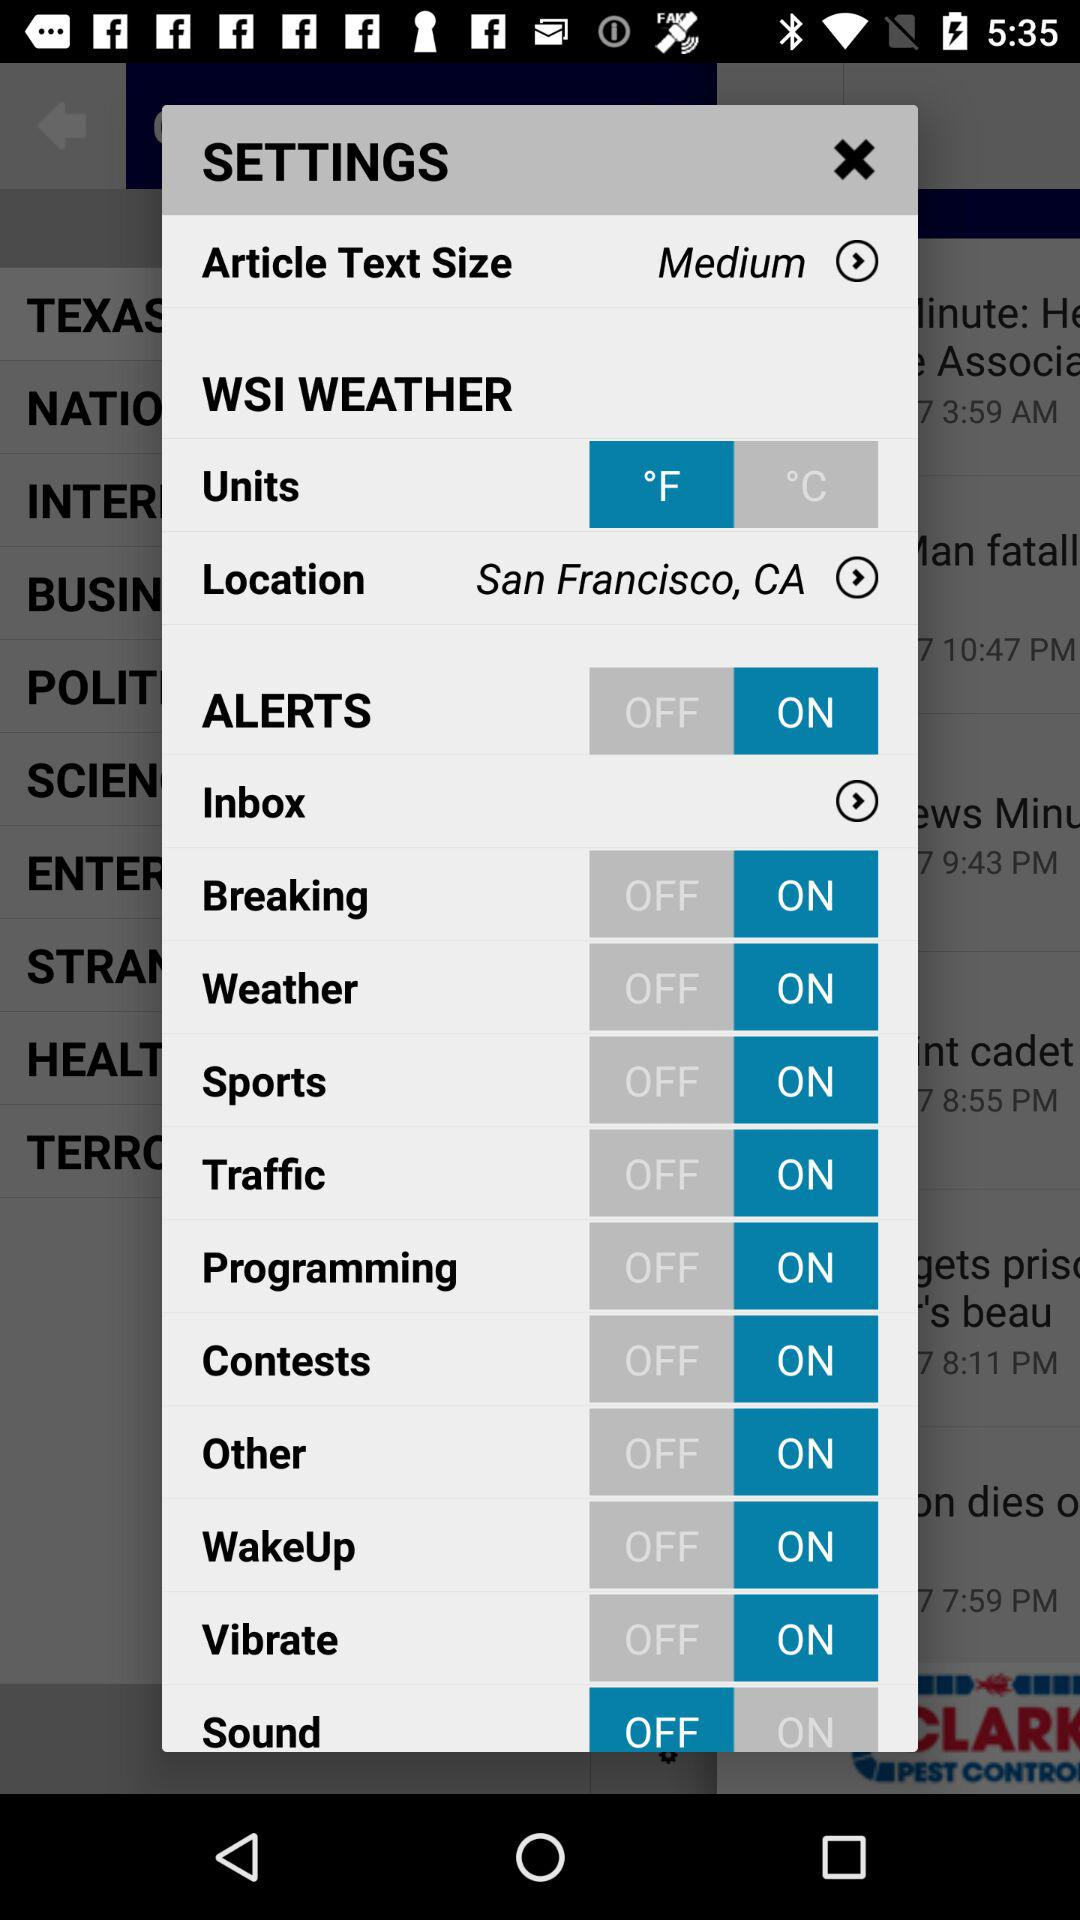What is the unit of temperature? The unit of temperature is °F. 